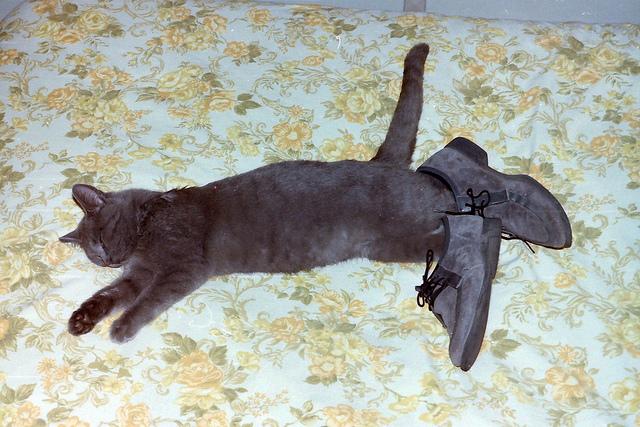Are the shoes too big for this cat?
Give a very brief answer. Yes. What is the cat doing?
Quick response, please. Sleeping. What fairy tale does this picture suggest?
Give a very brief answer. Puss in boots. 